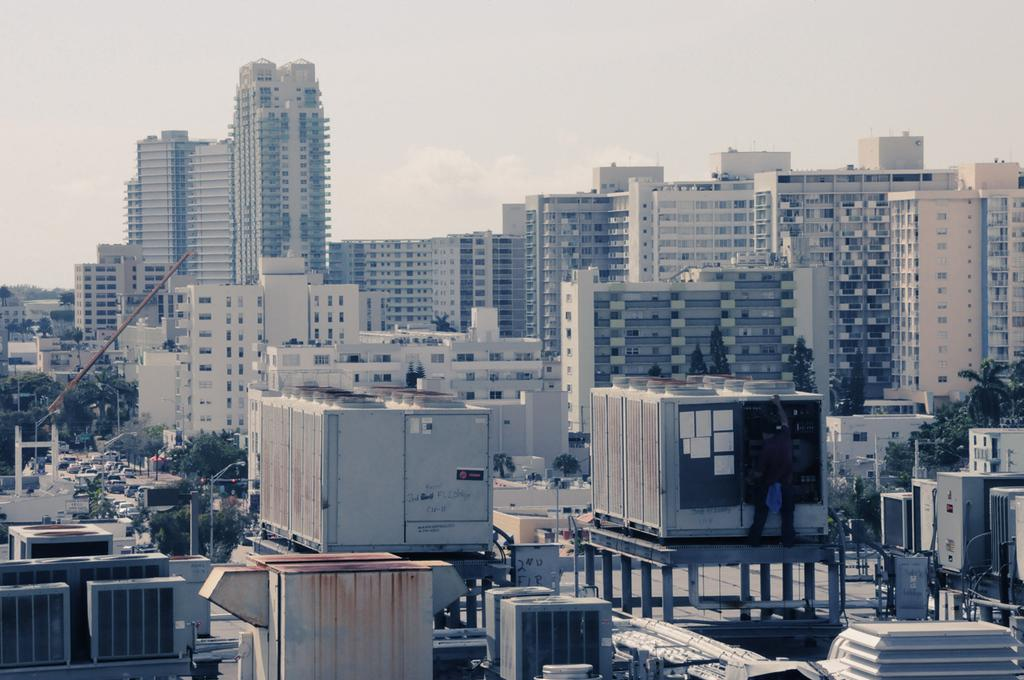What type of structures can be seen in the image? There are buildings in the image. What other natural elements are present in the image? There are trees in the image. What is happening on the road in the image? Vehicles are moving on the road in the image. What can be seen in the background of the image? The sky is visible in the background of the image. How would you describe the weather based on the sky in the image? The sky appears to be cloudy in the image. What type of bag is hanging from the tree in the image? There is no bag hanging from the tree in the image; only buildings, trees, vehicles, and a cloudy sky are present. What idea is being discussed by the buildings in the image? Buildings are inanimate objects and cannot discuss ideas; the image only shows their physical presence. 